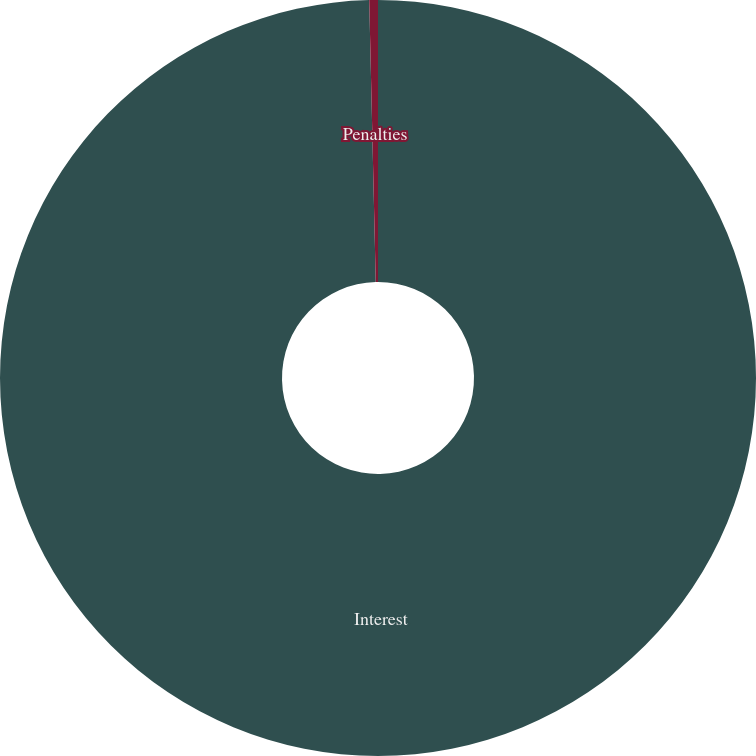Convert chart to OTSL. <chart><loc_0><loc_0><loc_500><loc_500><pie_chart><fcel>Interest<fcel>Penalties<nl><fcel>99.63%<fcel>0.37%<nl></chart> 